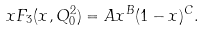Convert formula to latex. <formula><loc_0><loc_0><loc_500><loc_500>x F _ { 3 } ( x , Q _ { 0 } ^ { 2 } ) = A x ^ { B } ( 1 - x ) ^ { C } .</formula> 